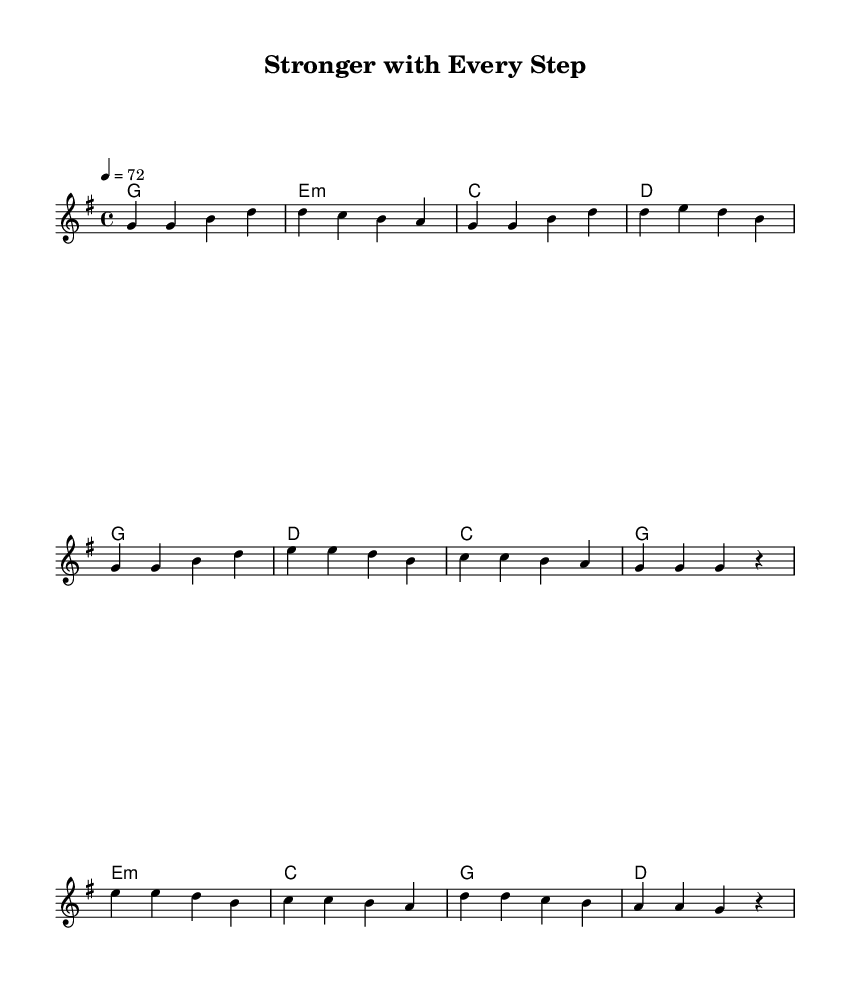What is the key signature of this music? The key signature is G major, which has one sharp (F#).
Answer: G major What is the time signature of this music? The time signature is 4/4, indicating there are four beats in each measure and the quarter note gets one beat.
Answer: 4/4 What is the tempo marking for this piece? The tempo marking indicates a speed of 72 beats per minute, which is moderate.
Answer: 72 How many distinct sections are present in the music? There are three sections present: the Verse, Chorus, and Bridge, each represented with different melodies and harmonies.
Answer: Three What is the primary subject of the lyrics in this piece? The primary subject of the lyrics revolves around self-discovery and personal growth, which is common in country rock ballads.
Answer: Self-discovery Which chord is used at the beginning of the chorus? The chord used at the beginning of the chorus is G major, which provides a strong foundation for the melody to follow.
Answer: G What type of song structure is predominantly used in this sheet music? The song structure follows a typical ballad format, alternating between specific sections (Verse, Chorus, Bridge) that explore emotional themes and storytelling.
Answer: Ballad format 